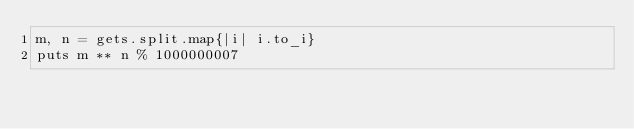<code> <loc_0><loc_0><loc_500><loc_500><_Ruby_>m, n = gets.split.map{|i| i.to_i}
puts m ** n % 1000000007</code> 